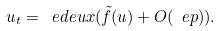<formula> <loc_0><loc_0><loc_500><loc_500>u _ { t } = \ e d e u x ( \tilde { f } ( u ) + O ( \ e p ) ) .</formula> 